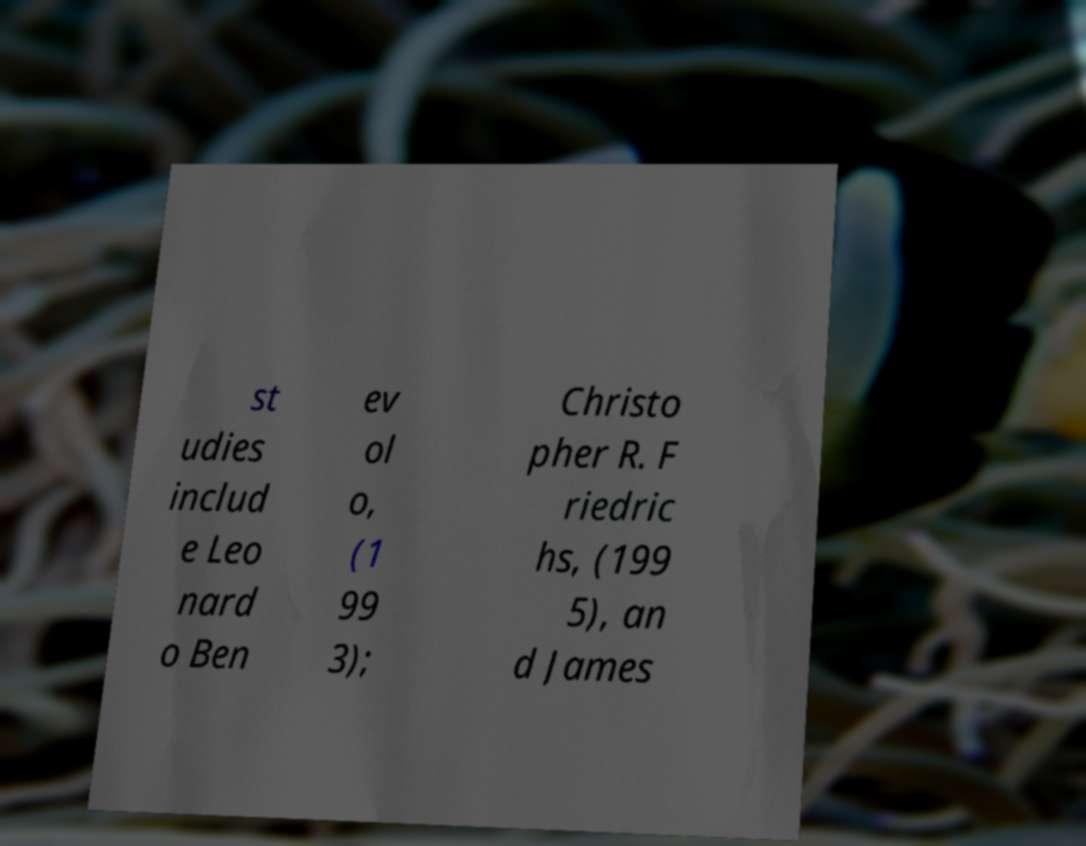Can you read and provide the text displayed in the image?This photo seems to have some interesting text. Can you extract and type it out for me? st udies includ e Leo nard o Ben ev ol o, (1 99 3); Christo pher R. F riedric hs, (199 5), an d James 